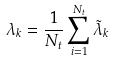Convert formula to latex. <formula><loc_0><loc_0><loc_500><loc_500>\lambda _ { k } = \frac { 1 } { N _ { t } } \sum _ { i = 1 } ^ { N _ { t } } \tilde { \lambda } _ { k }</formula> 